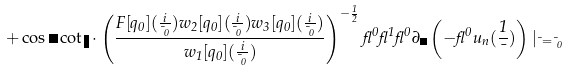<formula> <loc_0><loc_0><loc_500><loc_500>+ \cos \psi \cot \eta \cdot \left ( \frac { F [ q _ { 0 } ] ( \frac { i } { \mu _ { 0 } } ) w _ { 2 } [ q _ { 0 } ] ( \frac { i } { \mu _ { 0 } } ) w _ { 3 } [ q _ { 0 } ] ( \frac { i } { \mu _ { 0 } } ) } { w _ { 1 } [ q _ { 0 } ] ( \frac { i } { \mu _ { 0 } } ) } \right ) ^ { - \frac { 1 } { 2 } } \gamma ^ { 0 } \gamma ^ { 1 } \gamma ^ { 0 } \partial _ { \psi } \left ( - \gamma ^ { 0 } u _ { n } ( \frac { 1 } { \mu } ) \right ) | _ { \mu = \mu _ { 0 } }</formula> 